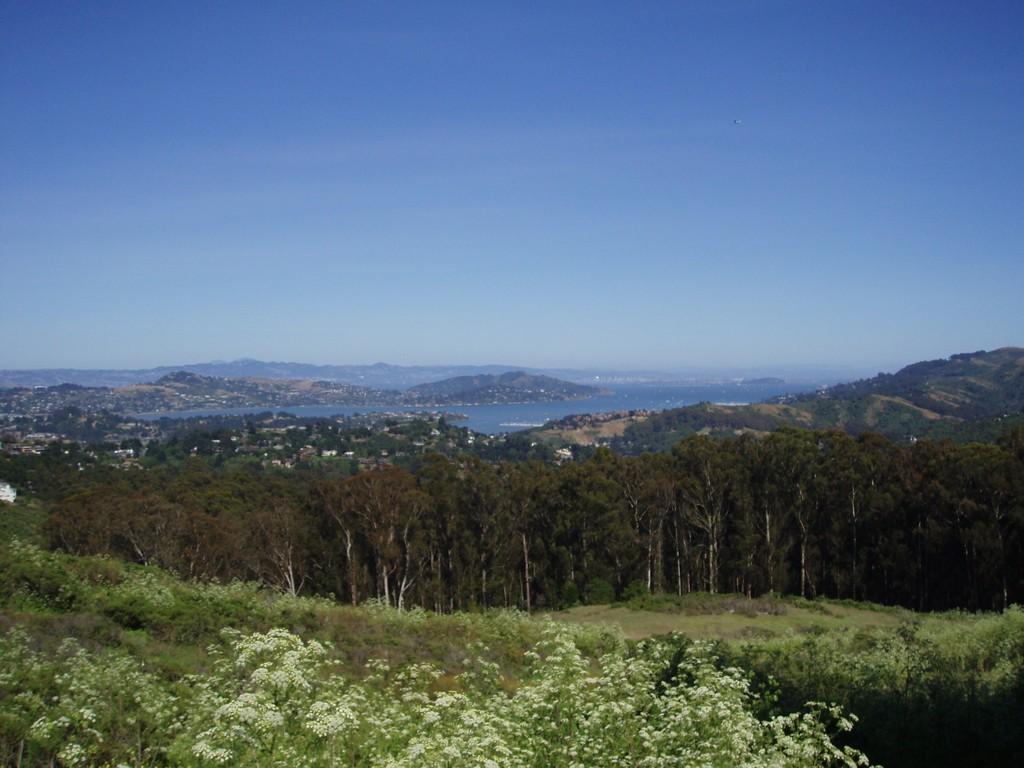Please provide a concise description of this image. In the image in the center we can see sky,hill,water,trees,plants,grass and flowers. 